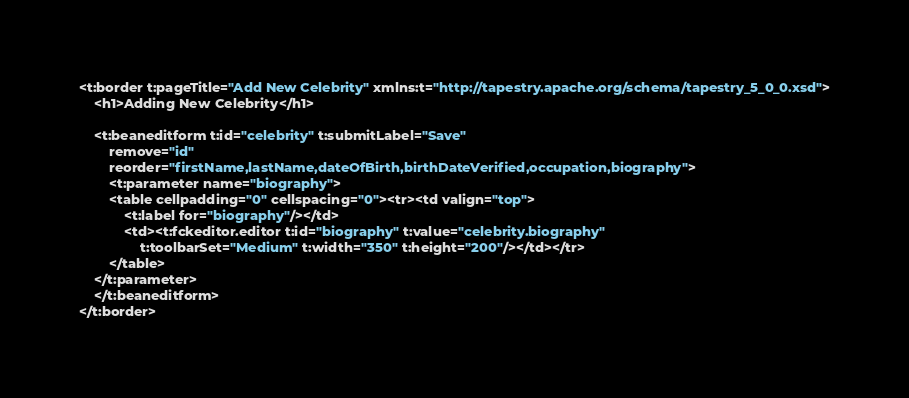Convert code to text. <code><loc_0><loc_0><loc_500><loc_500><_XML_><t:border t:pageTitle="Add New Celebrity" xmlns:t="http://tapestry.apache.org/schema/tapestry_5_0_0.xsd">
    <h1>Adding New Celebrity</h1>

    <t:beaneditform t:id="celebrity" t:submitLabel="Save"
    	remove="id"
    	reorder="firstName,lastName,dateOfBirth,birthDateVerified,occupation,biography">
    	<t:parameter name="biography">
    	<table cellpadding="0" cellspacing="0"><tr><td valign="top">
			<t:label for="biography"/></td>
			<td><t:fckeditor.editor t:id="biography" t:value="celebrity.biography" 
				t:toolbarSet="Medium" t:width="350" t:height="200"/></td></tr>
		</table>
	</t:parameter>
    </t:beaneditform>
</t:border></code> 